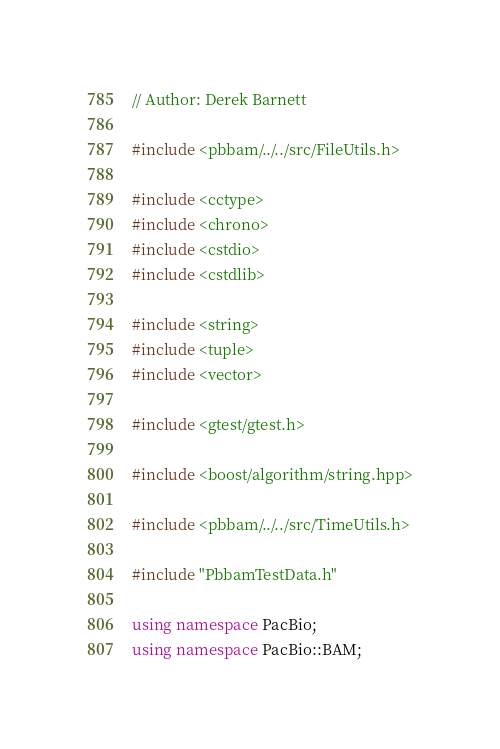Convert code to text. <code><loc_0><loc_0><loc_500><loc_500><_C++_>// Author: Derek Barnett

#include <pbbam/../../src/FileUtils.h>

#include <cctype>
#include <chrono>
#include <cstdio>
#include <cstdlib>

#include <string>
#include <tuple>
#include <vector>

#include <gtest/gtest.h>

#include <boost/algorithm/string.hpp>

#include <pbbam/../../src/TimeUtils.h>

#include "PbbamTestData.h"

using namespace PacBio;
using namespace PacBio::BAM;
</code> 